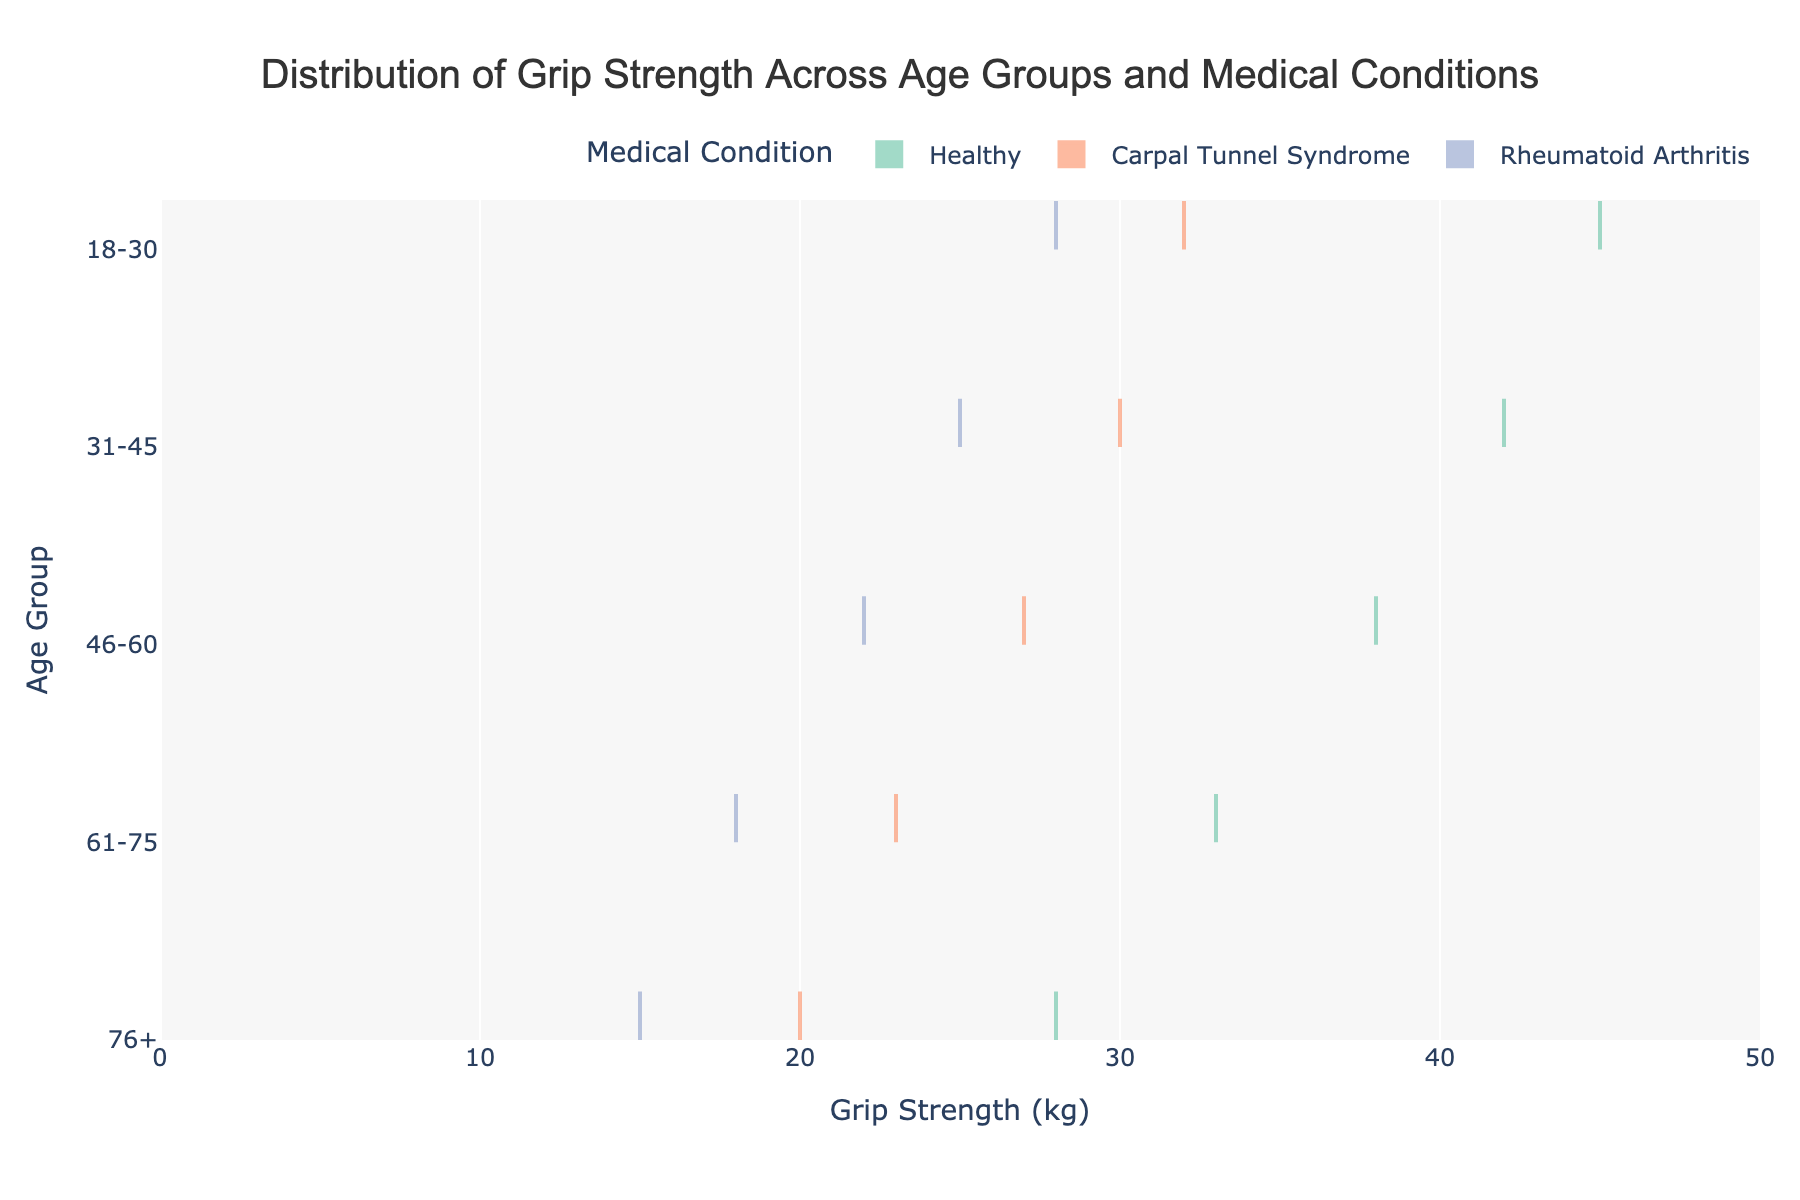What is the title of the figure? The title of the figure is displayed at the top. By reading the text at the top center of the plot, we can determine the title.
Answer: Distribution of Grip Strength Across Age Groups and Medical Conditions Which medical condition shows the lowest average grip strength? By observing the meanline visible on each violin plot for each condition, we can identify the medical condition with the lowest average grip strength across all age groups by identifying the plot that generally has the lowest meanline value on the x-axis.
Answer: Rheumatoid Arthritis How does the grip strength of the 'Healthy' group vary across different age groups? Observing the 'Healthy' group’s violin plots from top to bottom (76+ to 18-30 age groups), we can see how the width and meanline position of each plot change along the x-axis, indicating the variation in grip strength for this medical condition across age groups.
Answer: It decreases with increasing age For the age group 46-60, which medical condition has the highest grip strength? By looking at the violin plots corresponding to the age group 46-60 on the y-axis and comparing the x-axis positions of the meanlines, we can identify which condition has the highest grip strength.
Answer: Healthy What is the approximate range of grip strength for the 76+ age group with Carpal Tunnel Syndrome? Observing the width of the violin plot for Carpal Tunnel Syndrome in the 76+ age group, we can estimate the range of grip strength by determining the spread on the x-axis.
Answer: Approximately 15 to 25 kg How does the grip strength distribution for 'Rheumatoid Arthritis' compare between the 31-45 and 61-75 age groups? By comparing the position and spread of the violin plots for 'Rheumatoid Arthritis' in the 31-45 and 61-75 age groups, we can ascertain how the grip strength distribution differs between these age groups. Typically, we look at the central tendency and dispersion.
Answer: Lower in 61-75 age group Which age group shows the largest range of grip strength for the 'Healthy' condition? By comparing the width of the violin plots for the 'Healthy' condition across all age groups, we can identify which age group has the largest spread, indicating the largest range of grip strength values.
Answer: 46-60 What is the general trend of grip strength in relation to age among subjects with Carpal Tunnel Syndrome? Analyzing the meanlines and general distribution curves of the violin plots for Carpal Tunnel Syndrome across ascending age groups, we can determine the trend.
Answer: Decreases with age In the 31-45 age group, how does the grip strength of subjects with Carpal Tunnel Syndrome compare to those with Rheumatoid Arthritis? By observing the meanline positions within the violin plots for Carpal Tunnel Syndrome and Rheumatoid Arthritis in the 31-45 age group, we can directly compare the average grip strength of these conditions.
Answer: Carpal Tunnel Syndrome has higher grip strength 